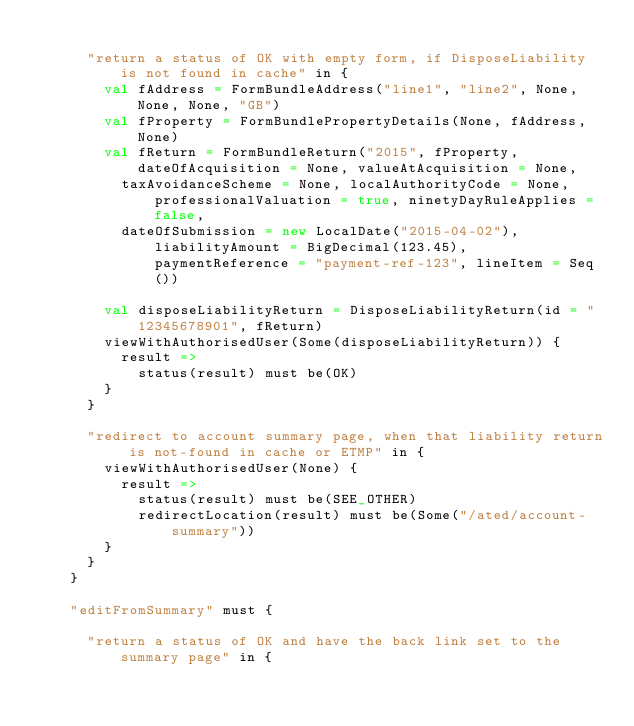Convert code to text. <code><loc_0><loc_0><loc_500><loc_500><_Scala_>
      "return a status of OK with empty form, if DisposeLiability is not found in cache" in {
        val fAddress = FormBundleAddress("line1", "line2", None, None, None, "GB")
        val fProperty = FormBundlePropertyDetails(None, fAddress, None)
        val fReturn = FormBundleReturn("2015", fProperty, dateOfAcquisition = None, valueAtAcquisition = None,
          taxAvoidanceScheme = None, localAuthorityCode = None, professionalValuation = true, ninetyDayRuleApplies = false,
          dateOfSubmission = new LocalDate("2015-04-02"), liabilityAmount = BigDecimal(123.45), paymentReference = "payment-ref-123", lineItem = Seq())

        val disposeLiabilityReturn = DisposeLiabilityReturn(id = "12345678901", fReturn)
        viewWithAuthorisedUser(Some(disposeLiabilityReturn)) {
          result =>
            status(result) must be(OK)
        }
      }

      "redirect to account summary page, when that liability return is not-found in cache or ETMP" in {
        viewWithAuthorisedUser(None) {
          result =>
            status(result) must be(SEE_OTHER)
            redirectLocation(result) must be(Some("/ated/account-summary"))
        }
      }
    }

    "editFromSummary" must {

      "return a status of OK and have the back link set to the summary page" in {</code> 